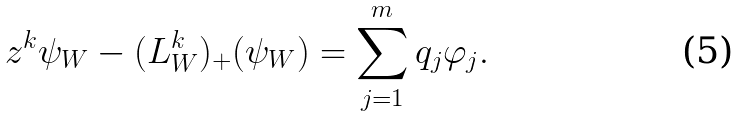<formula> <loc_0><loc_0><loc_500><loc_500>z ^ { k } \psi _ { W } - ( L ^ { k } _ { W } ) _ { + } ( \psi _ { W } ) = \sum ^ { m } _ { j = 1 } q _ { j } \varphi _ { j } .</formula> 